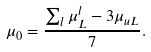<formula> <loc_0><loc_0><loc_500><loc_500>\mu _ { 0 } = \frac { \sum _ { l } \mu _ { L } ^ { l } - 3 \mu _ { u L } } { 7 } .</formula> 